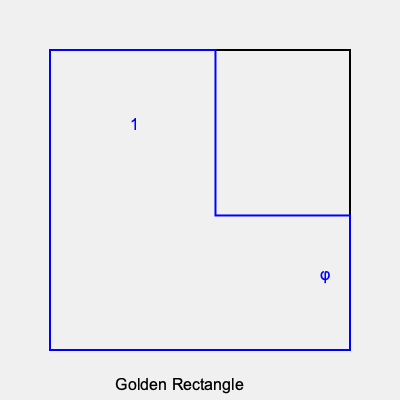In the context of artistic composition, how does the golden ratio ($\phi$) relate to the dimensions of a golden rectangle, and how might an artist use this principle to create a balanced and aesthetically pleasing artwork? To understand the relationship between the golden ratio and the golden rectangle in artistic composition, let's break it down step-by-step:

1. The golden ratio, denoted by $\phi$ (phi), is approximately equal to 1.618033988749895.

2. In a golden rectangle, the ratio of the longer side to the shorter side is equal to $\phi$. If we denote the shorter side as 1, then the longer side would be $\phi$.

3. Mathematically, this can be expressed as:
   $$\frac{\text{longer side}}{\text{shorter side}} = \phi$$

4. The golden rectangle has unique properties:
   a. When you remove a square from a golden rectangle, the remaining rectangle is also a golden rectangle.
   b. This process can be repeated infinitely, creating a spiral pattern known as the golden spiral.

5. Artists can use the golden ratio in their compositions by:
   a. Dividing their canvas according to the golden ratio (e.g., placing key elements at the 1:1.618 points).
   b. Using the golden rectangle as a frame for their artwork or for key elements within the piece.
   c. Incorporating the golden spiral to guide the viewer's eye through the composition.

6. The golden ratio is found in nature (e.g., in the arrangement of leaves on some plants, the spiral of a nautilus shell), which may contribute to its perceived aesthetic appeal.

7. By using the golden ratio, artists can create a sense of balance and harmony in their work, as the proportions are believed to be inherently pleasing to the human eye.

8. However, it's important to note that while the golden ratio can be a useful tool, it shouldn't be considered a rigid rule. Artistic creativity often involves breaking or reinterpreting such principles.

An artist can use this knowledge to create balanced compositions by consciously incorporating golden ratio proportions, while also allowing for intuitive and creative departures from this mathematical principle.
Answer: The golden ratio ($\phi \approx 1.618$) defines the proportion of a golden rectangle's sides, guiding artists in creating balanced compositions through strategic element placement and proportional relationships. 